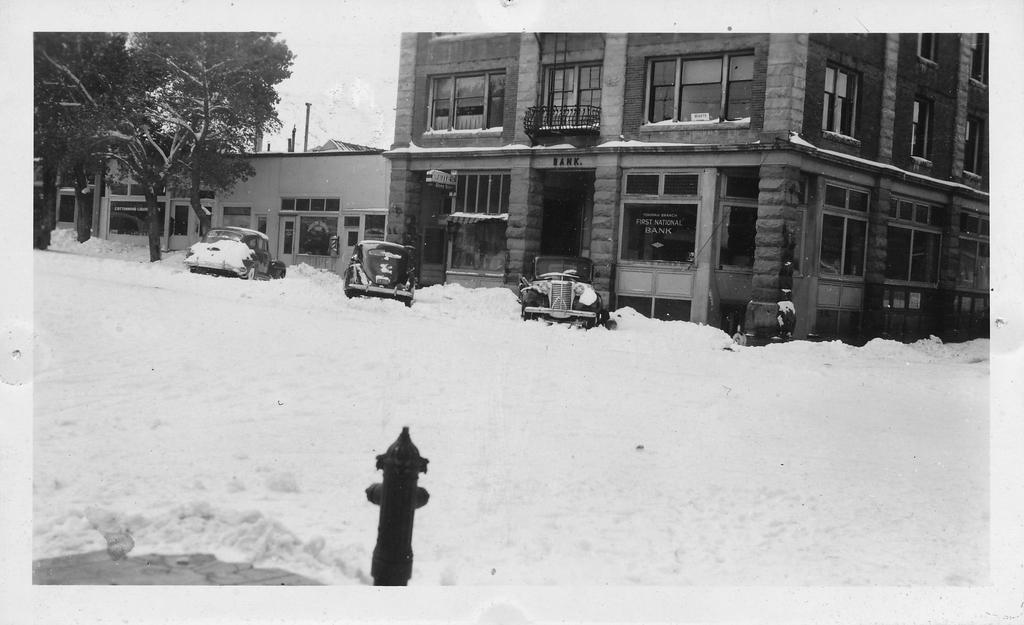What is the color scheme of the image? The image is black and white. What object can be seen in the image that is used for firefighting? There is a hydrant in the image. What weather condition is depicted in the image? There is snow in the image. What type of transportation is visible in the image? There are vehicles in the image. What type of vegetation is present in the image? There are trees in the image. What type of structures are present in the image? There are poles and buildings in the image. What is visible in the background of the image? The sky is visible in the background of the image. What type of plastic material is covering the trees in the image? There is no plastic material covering the trees in the image; the trees are visible in their natural state. 